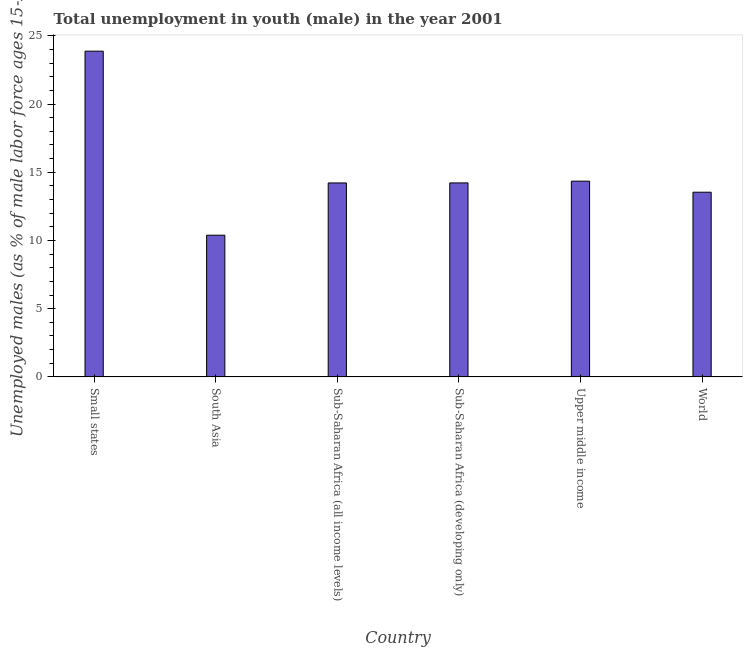Does the graph contain grids?
Keep it short and to the point. No. What is the title of the graph?
Your response must be concise. Total unemployment in youth (male) in the year 2001. What is the label or title of the Y-axis?
Keep it short and to the point. Unemployed males (as % of male labor force ages 15-24). What is the unemployed male youth population in Upper middle income?
Keep it short and to the point. 14.35. Across all countries, what is the maximum unemployed male youth population?
Provide a short and direct response. 23.88. Across all countries, what is the minimum unemployed male youth population?
Keep it short and to the point. 10.39. In which country was the unemployed male youth population maximum?
Ensure brevity in your answer.  Small states. What is the sum of the unemployed male youth population?
Give a very brief answer. 90.59. What is the difference between the unemployed male youth population in South Asia and Upper middle income?
Your answer should be very brief. -3.96. What is the average unemployed male youth population per country?
Provide a short and direct response. 15.1. What is the median unemployed male youth population?
Keep it short and to the point. 14.22. In how many countries, is the unemployed male youth population greater than 17 %?
Your answer should be compact. 1. Is the unemployed male youth population in Upper middle income less than that in World?
Provide a succinct answer. No. What is the difference between the highest and the second highest unemployed male youth population?
Make the answer very short. 9.53. Is the sum of the unemployed male youth population in South Asia and World greater than the maximum unemployed male youth population across all countries?
Your response must be concise. Yes. What is the difference between the highest and the lowest unemployed male youth population?
Make the answer very short. 13.49. In how many countries, is the unemployed male youth population greater than the average unemployed male youth population taken over all countries?
Offer a very short reply. 1. How many bars are there?
Make the answer very short. 6. Are all the bars in the graph horizontal?
Your answer should be very brief. No. How many countries are there in the graph?
Keep it short and to the point. 6. Are the values on the major ticks of Y-axis written in scientific E-notation?
Give a very brief answer. No. What is the Unemployed males (as % of male labor force ages 15-24) of Small states?
Your answer should be compact. 23.88. What is the Unemployed males (as % of male labor force ages 15-24) of South Asia?
Keep it short and to the point. 10.39. What is the Unemployed males (as % of male labor force ages 15-24) of Sub-Saharan Africa (all income levels)?
Your answer should be compact. 14.22. What is the Unemployed males (as % of male labor force ages 15-24) in Sub-Saharan Africa (developing only)?
Make the answer very short. 14.22. What is the Unemployed males (as % of male labor force ages 15-24) of Upper middle income?
Keep it short and to the point. 14.35. What is the Unemployed males (as % of male labor force ages 15-24) of World?
Make the answer very short. 13.54. What is the difference between the Unemployed males (as % of male labor force ages 15-24) in Small states and South Asia?
Your answer should be very brief. 13.49. What is the difference between the Unemployed males (as % of male labor force ages 15-24) in Small states and Sub-Saharan Africa (all income levels)?
Ensure brevity in your answer.  9.66. What is the difference between the Unemployed males (as % of male labor force ages 15-24) in Small states and Sub-Saharan Africa (developing only)?
Your answer should be compact. 9.66. What is the difference between the Unemployed males (as % of male labor force ages 15-24) in Small states and Upper middle income?
Provide a short and direct response. 9.53. What is the difference between the Unemployed males (as % of male labor force ages 15-24) in Small states and World?
Provide a short and direct response. 10.34. What is the difference between the Unemployed males (as % of male labor force ages 15-24) in South Asia and Sub-Saharan Africa (all income levels)?
Ensure brevity in your answer.  -3.83. What is the difference between the Unemployed males (as % of male labor force ages 15-24) in South Asia and Sub-Saharan Africa (developing only)?
Offer a terse response. -3.83. What is the difference between the Unemployed males (as % of male labor force ages 15-24) in South Asia and Upper middle income?
Provide a short and direct response. -3.96. What is the difference between the Unemployed males (as % of male labor force ages 15-24) in South Asia and World?
Provide a short and direct response. -3.15. What is the difference between the Unemployed males (as % of male labor force ages 15-24) in Sub-Saharan Africa (all income levels) and Sub-Saharan Africa (developing only)?
Give a very brief answer. -0. What is the difference between the Unemployed males (as % of male labor force ages 15-24) in Sub-Saharan Africa (all income levels) and Upper middle income?
Provide a succinct answer. -0.13. What is the difference between the Unemployed males (as % of male labor force ages 15-24) in Sub-Saharan Africa (all income levels) and World?
Make the answer very short. 0.68. What is the difference between the Unemployed males (as % of male labor force ages 15-24) in Sub-Saharan Africa (developing only) and Upper middle income?
Your answer should be very brief. -0.13. What is the difference between the Unemployed males (as % of male labor force ages 15-24) in Sub-Saharan Africa (developing only) and World?
Give a very brief answer. 0.68. What is the difference between the Unemployed males (as % of male labor force ages 15-24) in Upper middle income and World?
Offer a very short reply. 0.81. What is the ratio of the Unemployed males (as % of male labor force ages 15-24) in Small states to that in South Asia?
Offer a very short reply. 2.3. What is the ratio of the Unemployed males (as % of male labor force ages 15-24) in Small states to that in Sub-Saharan Africa (all income levels)?
Provide a short and direct response. 1.68. What is the ratio of the Unemployed males (as % of male labor force ages 15-24) in Small states to that in Sub-Saharan Africa (developing only)?
Your answer should be very brief. 1.68. What is the ratio of the Unemployed males (as % of male labor force ages 15-24) in Small states to that in Upper middle income?
Your answer should be compact. 1.66. What is the ratio of the Unemployed males (as % of male labor force ages 15-24) in Small states to that in World?
Your answer should be very brief. 1.76. What is the ratio of the Unemployed males (as % of male labor force ages 15-24) in South Asia to that in Sub-Saharan Africa (all income levels)?
Offer a very short reply. 0.73. What is the ratio of the Unemployed males (as % of male labor force ages 15-24) in South Asia to that in Sub-Saharan Africa (developing only)?
Provide a short and direct response. 0.73. What is the ratio of the Unemployed males (as % of male labor force ages 15-24) in South Asia to that in Upper middle income?
Give a very brief answer. 0.72. What is the ratio of the Unemployed males (as % of male labor force ages 15-24) in South Asia to that in World?
Offer a terse response. 0.77. What is the ratio of the Unemployed males (as % of male labor force ages 15-24) in Sub-Saharan Africa (all income levels) to that in Upper middle income?
Provide a short and direct response. 0.99. What is the ratio of the Unemployed males (as % of male labor force ages 15-24) in Sub-Saharan Africa (all income levels) to that in World?
Give a very brief answer. 1.05. What is the ratio of the Unemployed males (as % of male labor force ages 15-24) in Sub-Saharan Africa (developing only) to that in World?
Your answer should be compact. 1.05. What is the ratio of the Unemployed males (as % of male labor force ages 15-24) in Upper middle income to that in World?
Make the answer very short. 1.06. 